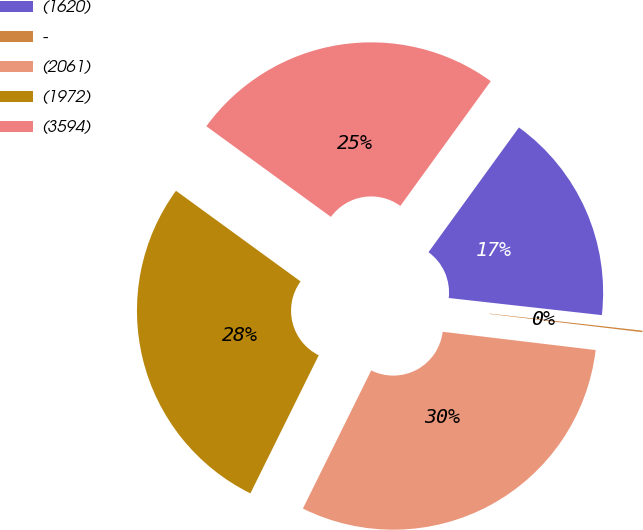Convert chart to OTSL. <chart><loc_0><loc_0><loc_500><loc_500><pie_chart><fcel>(1620)<fcel>-<fcel>(2061)<fcel>(1972)<fcel>(3594)<nl><fcel>16.79%<fcel>0.12%<fcel>30.42%<fcel>27.7%<fcel>24.97%<nl></chart> 